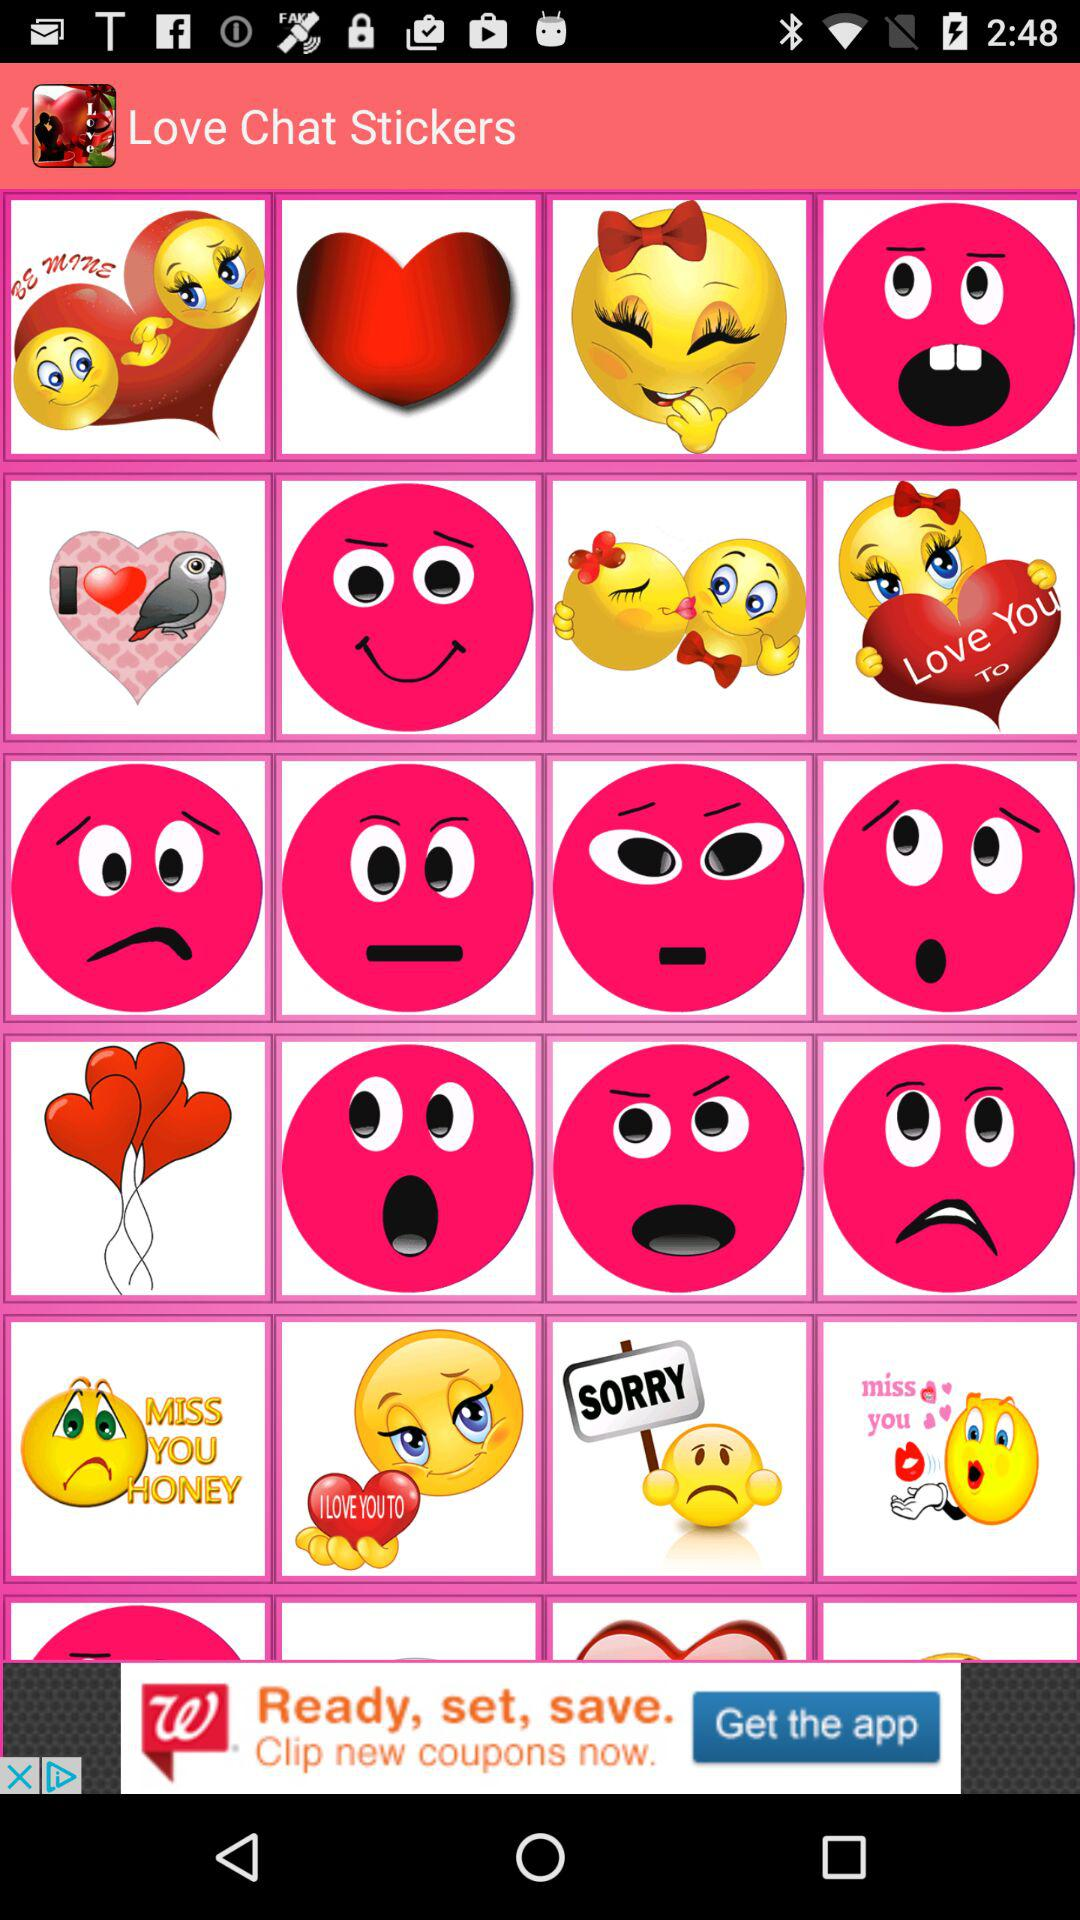Who is sending love stickers?
When the provided information is insufficient, respond with <no answer>. <no answer> 